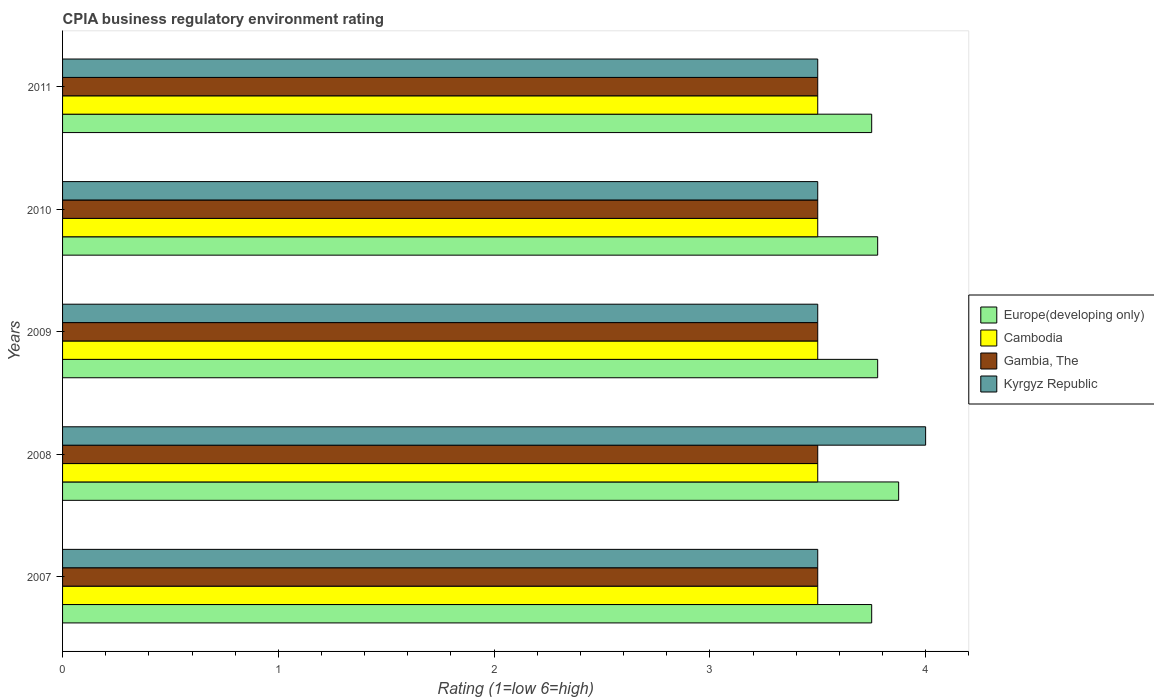How many groups of bars are there?
Give a very brief answer. 5. How many bars are there on the 5th tick from the top?
Offer a very short reply. 4. How many bars are there on the 1st tick from the bottom?
Keep it short and to the point. 4. What is the label of the 2nd group of bars from the top?
Offer a very short reply. 2010. In how many cases, is the number of bars for a given year not equal to the number of legend labels?
Your response must be concise. 0. Across all years, what is the maximum CPIA rating in Europe(developing only)?
Offer a very short reply. 3.88. What is the difference between the CPIA rating in Gambia, The in 2009 and that in 2010?
Give a very brief answer. 0. What is the difference between the CPIA rating in Cambodia in 2009 and the CPIA rating in Europe(developing only) in 2011?
Your response must be concise. -0.25. What is the average CPIA rating in Gambia, The per year?
Provide a succinct answer. 3.5. In the year 2010, what is the difference between the CPIA rating in Cambodia and CPIA rating in Europe(developing only)?
Offer a terse response. -0.28. What is the difference between the highest and the lowest CPIA rating in Europe(developing only)?
Offer a terse response. 0.12. What does the 4th bar from the top in 2011 represents?
Make the answer very short. Europe(developing only). What does the 3rd bar from the bottom in 2010 represents?
Provide a short and direct response. Gambia, The. Are all the bars in the graph horizontal?
Ensure brevity in your answer.  Yes. How many years are there in the graph?
Provide a short and direct response. 5. What is the difference between two consecutive major ticks on the X-axis?
Offer a very short reply. 1. Are the values on the major ticks of X-axis written in scientific E-notation?
Your response must be concise. No. Does the graph contain any zero values?
Offer a very short reply. No. Does the graph contain grids?
Give a very brief answer. No. How many legend labels are there?
Provide a succinct answer. 4. What is the title of the graph?
Provide a short and direct response. CPIA business regulatory environment rating. What is the Rating (1=low 6=high) in Europe(developing only) in 2007?
Provide a short and direct response. 3.75. What is the Rating (1=low 6=high) of Cambodia in 2007?
Ensure brevity in your answer.  3.5. What is the Rating (1=low 6=high) in Gambia, The in 2007?
Offer a terse response. 3.5. What is the Rating (1=low 6=high) of Europe(developing only) in 2008?
Offer a terse response. 3.88. What is the Rating (1=low 6=high) in Cambodia in 2008?
Provide a succinct answer. 3.5. What is the Rating (1=low 6=high) in Gambia, The in 2008?
Offer a terse response. 3.5. What is the Rating (1=low 6=high) of Europe(developing only) in 2009?
Provide a succinct answer. 3.78. What is the Rating (1=low 6=high) in Europe(developing only) in 2010?
Your answer should be compact. 3.78. What is the Rating (1=low 6=high) in Europe(developing only) in 2011?
Make the answer very short. 3.75. Across all years, what is the maximum Rating (1=low 6=high) in Europe(developing only)?
Offer a terse response. 3.88. Across all years, what is the maximum Rating (1=low 6=high) of Gambia, The?
Provide a succinct answer. 3.5. Across all years, what is the minimum Rating (1=low 6=high) in Europe(developing only)?
Keep it short and to the point. 3.75. Across all years, what is the minimum Rating (1=low 6=high) in Cambodia?
Provide a succinct answer. 3.5. Across all years, what is the minimum Rating (1=low 6=high) in Gambia, The?
Make the answer very short. 3.5. Across all years, what is the minimum Rating (1=low 6=high) in Kyrgyz Republic?
Provide a short and direct response. 3.5. What is the total Rating (1=low 6=high) of Europe(developing only) in the graph?
Provide a short and direct response. 18.93. What is the total Rating (1=low 6=high) of Cambodia in the graph?
Offer a very short reply. 17.5. What is the difference between the Rating (1=low 6=high) in Europe(developing only) in 2007 and that in 2008?
Your answer should be compact. -0.12. What is the difference between the Rating (1=low 6=high) of Cambodia in 2007 and that in 2008?
Offer a very short reply. 0. What is the difference between the Rating (1=low 6=high) of Europe(developing only) in 2007 and that in 2009?
Your response must be concise. -0.03. What is the difference between the Rating (1=low 6=high) in Cambodia in 2007 and that in 2009?
Your answer should be compact. 0. What is the difference between the Rating (1=low 6=high) of Gambia, The in 2007 and that in 2009?
Offer a terse response. 0. What is the difference between the Rating (1=low 6=high) of Kyrgyz Republic in 2007 and that in 2009?
Your answer should be very brief. 0. What is the difference between the Rating (1=low 6=high) of Europe(developing only) in 2007 and that in 2010?
Provide a succinct answer. -0.03. What is the difference between the Rating (1=low 6=high) in Gambia, The in 2007 and that in 2010?
Provide a short and direct response. 0. What is the difference between the Rating (1=low 6=high) of Kyrgyz Republic in 2007 and that in 2010?
Offer a terse response. 0. What is the difference between the Rating (1=low 6=high) of Cambodia in 2007 and that in 2011?
Provide a short and direct response. 0. What is the difference between the Rating (1=low 6=high) in Gambia, The in 2007 and that in 2011?
Give a very brief answer. 0. What is the difference between the Rating (1=low 6=high) of Kyrgyz Republic in 2007 and that in 2011?
Make the answer very short. 0. What is the difference between the Rating (1=low 6=high) in Europe(developing only) in 2008 and that in 2009?
Your answer should be compact. 0.1. What is the difference between the Rating (1=low 6=high) in Cambodia in 2008 and that in 2009?
Provide a succinct answer. 0. What is the difference between the Rating (1=low 6=high) in Europe(developing only) in 2008 and that in 2010?
Give a very brief answer. 0.1. What is the difference between the Rating (1=low 6=high) of Gambia, The in 2008 and that in 2010?
Your answer should be compact. 0. What is the difference between the Rating (1=low 6=high) in Kyrgyz Republic in 2008 and that in 2010?
Ensure brevity in your answer.  0.5. What is the difference between the Rating (1=low 6=high) of Cambodia in 2008 and that in 2011?
Your answer should be compact. 0. What is the difference between the Rating (1=low 6=high) of Europe(developing only) in 2009 and that in 2010?
Provide a succinct answer. 0. What is the difference between the Rating (1=low 6=high) in Gambia, The in 2009 and that in 2010?
Ensure brevity in your answer.  0. What is the difference between the Rating (1=low 6=high) in Kyrgyz Republic in 2009 and that in 2010?
Ensure brevity in your answer.  0. What is the difference between the Rating (1=low 6=high) of Europe(developing only) in 2009 and that in 2011?
Provide a succinct answer. 0.03. What is the difference between the Rating (1=low 6=high) of Europe(developing only) in 2010 and that in 2011?
Provide a short and direct response. 0.03. What is the difference between the Rating (1=low 6=high) of Cambodia in 2010 and that in 2011?
Keep it short and to the point. 0. What is the difference between the Rating (1=low 6=high) in Kyrgyz Republic in 2010 and that in 2011?
Make the answer very short. 0. What is the difference between the Rating (1=low 6=high) in Europe(developing only) in 2007 and the Rating (1=low 6=high) in Cambodia in 2008?
Keep it short and to the point. 0.25. What is the difference between the Rating (1=low 6=high) of Europe(developing only) in 2007 and the Rating (1=low 6=high) of Gambia, The in 2008?
Make the answer very short. 0.25. What is the difference between the Rating (1=low 6=high) in Europe(developing only) in 2007 and the Rating (1=low 6=high) in Kyrgyz Republic in 2008?
Offer a very short reply. -0.25. What is the difference between the Rating (1=low 6=high) in Cambodia in 2007 and the Rating (1=low 6=high) in Kyrgyz Republic in 2008?
Offer a very short reply. -0.5. What is the difference between the Rating (1=low 6=high) in Gambia, The in 2007 and the Rating (1=low 6=high) in Kyrgyz Republic in 2008?
Give a very brief answer. -0.5. What is the difference between the Rating (1=low 6=high) of Europe(developing only) in 2007 and the Rating (1=low 6=high) of Cambodia in 2009?
Offer a terse response. 0.25. What is the difference between the Rating (1=low 6=high) in Europe(developing only) in 2007 and the Rating (1=low 6=high) in Gambia, The in 2009?
Ensure brevity in your answer.  0.25. What is the difference between the Rating (1=low 6=high) in Cambodia in 2007 and the Rating (1=low 6=high) in Gambia, The in 2009?
Your answer should be very brief. 0. What is the difference between the Rating (1=low 6=high) in Europe(developing only) in 2007 and the Rating (1=low 6=high) in Cambodia in 2010?
Provide a short and direct response. 0.25. What is the difference between the Rating (1=low 6=high) in Europe(developing only) in 2007 and the Rating (1=low 6=high) in Gambia, The in 2010?
Your answer should be very brief. 0.25. What is the difference between the Rating (1=low 6=high) in Cambodia in 2007 and the Rating (1=low 6=high) in Gambia, The in 2010?
Offer a very short reply. 0. What is the difference between the Rating (1=low 6=high) in Europe(developing only) in 2007 and the Rating (1=low 6=high) in Cambodia in 2011?
Your answer should be very brief. 0.25. What is the difference between the Rating (1=low 6=high) of Europe(developing only) in 2007 and the Rating (1=low 6=high) of Gambia, The in 2011?
Ensure brevity in your answer.  0.25. What is the difference between the Rating (1=low 6=high) of Europe(developing only) in 2007 and the Rating (1=low 6=high) of Kyrgyz Republic in 2011?
Ensure brevity in your answer.  0.25. What is the difference between the Rating (1=low 6=high) of Cambodia in 2007 and the Rating (1=low 6=high) of Gambia, The in 2011?
Make the answer very short. 0. What is the difference between the Rating (1=low 6=high) in Europe(developing only) in 2008 and the Rating (1=low 6=high) in Cambodia in 2009?
Keep it short and to the point. 0.38. What is the difference between the Rating (1=low 6=high) of Europe(developing only) in 2008 and the Rating (1=low 6=high) of Gambia, The in 2009?
Give a very brief answer. 0.38. What is the difference between the Rating (1=low 6=high) in Europe(developing only) in 2008 and the Rating (1=low 6=high) in Cambodia in 2010?
Give a very brief answer. 0.38. What is the difference between the Rating (1=low 6=high) of Europe(developing only) in 2008 and the Rating (1=low 6=high) of Kyrgyz Republic in 2010?
Offer a very short reply. 0.38. What is the difference between the Rating (1=low 6=high) in Cambodia in 2008 and the Rating (1=low 6=high) in Gambia, The in 2010?
Offer a terse response. 0. What is the difference between the Rating (1=low 6=high) in Cambodia in 2008 and the Rating (1=low 6=high) in Kyrgyz Republic in 2010?
Ensure brevity in your answer.  0. What is the difference between the Rating (1=low 6=high) of Gambia, The in 2008 and the Rating (1=low 6=high) of Kyrgyz Republic in 2010?
Your answer should be very brief. 0. What is the difference between the Rating (1=low 6=high) of Europe(developing only) in 2008 and the Rating (1=low 6=high) of Cambodia in 2011?
Provide a short and direct response. 0.38. What is the difference between the Rating (1=low 6=high) of Cambodia in 2008 and the Rating (1=low 6=high) of Kyrgyz Republic in 2011?
Offer a terse response. 0. What is the difference between the Rating (1=low 6=high) in Europe(developing only) in 2009 and the Rating (1=low 6=high) in Cambodia in 2010?
Make the answer very short. 0.28. What is the difference between the Rating (1=low 6=high) in Europe(developing only) in 2009 and the Rating (1=low 6=high) in Gambia, The in 2010?
Provide a succinct answer. 0.28. What is the difference between the Rating (1=low 6=high) of Europe(developing only) in 2009 and the Rating (1=low 6=high) of Kyrgyz Republic in 2010?
Your answer should be very brief. 0.28. What is the difference between the Rating (1=low 6=high) in Cambodia in 2009 and the Rating (1=low 6=high) in Gambia, The in 2010?
Provide a succinct answer. 0. What is the difference between the Rating (1=low 6=high) of Europe(developing only) in 2009 and the Rating (1=low 6=high) of Cambodia in 2011?
Keep it short and to the point. 0.28. What is the difference between the Rating (1=low 6=high) in Europe(developing only) in 2009 and the Rating (1=low 6=high) in Gambia, The in 2011?
Provide a short and direct response. 0.28. What is the difference between the Rating (1=low 6=high) in Europe(developing only) in 2009 and the Rating (1=low 6=high) in Kyrgyz Republic in 2011?
Your response must be concise. 0.28. What is the difference between the Rating (1=low 6=high) in Cambodia in 2009 and the Rating (1=low 6=high) in Kyrgyz Republic in 2011?
Make the answer very short. 0. What is the difference between the Rating (1=low 6=high) of Gambia, The in 2009 and the Rating (1=low 6=high) of Kyrgyz Republic in 2011?
Provide a succinct answer. 0. What is the difference between the Rating (1=low 6=high) of Europe(developing only) in 2010 and the Rating (1=low 6=high) of Cambodia in 2011?
Your response must be concise. 0.28. What is the difference between the Rating (1=low 6=high) in Europe(developing only) in 2010 and the Rating (1=low 6=high) in Gambia, The in 2011?
Offer a very short reply. 0.28. What is the difference between the Rating (1=low 6=high) in Europe(developing only) in 2010 and the Rating (1=low 6=high) in Kyrgyz Republic in 2011?
Your answer should be very brief. 0.28. What is the average Rating (1=low 6=high) in Europe(developing only) per year?
Ensure brevity in your answer.  3.79. What is the average Rating (1=low 6=high) of Kyrgyz Republic per year?
Provide a short and direct response. 3.6. In the year 2007, what is the difference between the Rating (1=low 6=high) in Europe(developing only) and Rating (1=low 6=high) in Cambodia?
Your response must be concise. 0.25. In the year 2007, what is the difference between the Rating (1=low 6=high) in Europe(developing only) and Rating (1=low 6=high) in Kyrgyz Republic?
Offer a terse response. 0.25. In the year 2007, what is the difference between the Rating (1=low 6=high) in Cambodia and Rating (1=low 6=high) in Gambia, The?
Offer a very short reply. 0. In the year 2008, what is the difference between the Rating (1=low 6=high) in Europe(developing only) and Rating (1=low 6=high) in Gambia, The?
Your response must be concise. 0.38. In the year 2008, what is the difference between the Rating (1=low 6=high) of Europe(developing only) and Rating (1=low 6=high) of Kyrgyz Republic?
Offer a terse response. -0.12. In the year 2009, what is the difference between the Rating (1=low 6=high) in Europe(developing only) and Rating (1=low 6=high) in Cambodia?
Your answer should be very brief. 0.28. In the year 2009, what is the difference between the Rating (1=low 6=high) in Europe(developing only) and Rating (1=low 6=high) in Gambia, The?
Keep it short and to the point. 0.28. In the year 2009, what is the difference between the Rating (1=low 6=high) in Europe(developing only) and Rating (1=low 6=high) in Kyrgyz Republic?
Your answer should be compact. 0.28. In the year 2010, what is the difference between the Rating (1=low 6=high) in Europe(developing only) and Rating (1=low 6=high) in Cambodia?
Ensure brevity in your answer.  0.28. In the year 2010, what is the difference between the Rating (1=low 6=high) of Europe(developing only) and Rating (1=low 6=high) of Gambia, The?
Make the answer very short. 0.28. In the year 2010, what is the difference between the Rating (1=low 6=high) in Europe(developing only) and Rating (1=low 6=high) in Kyrgyz Republic?
Your response must be concise. 0.28. In the year 2011, what is the difference between the Rating (1=low 6=high) of Europe(developing only) and Rating (1=low 6=high) of Cambodia?
Your response must be concise. 0.25. In the year 2011, what is the difference between the Rating (1=low 6=high) in Cambodia and Rating (1=low 6=high) in Gambia, The?
Your response must be concise. 0. In the year 2011, what is the difference between the Rating (1=low 6=high) of Cambodia and Rating (1=low 6=high) of Kyrgyz Republic?
Your response must be concise. 0. What is the ratio of the Rating (1=low 6=high) of Europe(developing only) in 2007 to that in 2008?
Ensure brevity in your answer.  0.97. What is the ratio of the Rating (1=low 6=high) of Europe(developing only) in 2007 to that in 2009?
Make the answer very short. 0.99. What is the ratio of the Rating (1=low 6=high) in Gambia, The in 2007 to that in 2009?
Provide a short and direct response. 1. What is the ratio of the Rating (1=low 6=high) in Europe(developing only) in 2007 to that in 2010?
Your answer should be very brief. 0.99. What is the ratio of the Rating (1=low 6=high) in Gambia, The in 2007 to that in 2010?
Make the answer very short. 1. What is the ratio of the Rating (1=low 6=high) in Kyrgyz Republic in 2007 to that in 2010?
Provide a succinct answer. 1. What is the ratio of the Rating (1=low 6=high) of Europe(developing only) in 2007 to that in 2011?
Keep it short and to the point. 1. What is the ratio of the Rating (1=low 6=high) of Cambodia in 2007 to that in 2011?
Provide a short and direct response. 1. What is the ratio of the Rating (1=low 6=high) of Kyrgyz Republic in 2007 to that in 2011?
Provide a succinct answer. 1. What is the ratio of the Rating (1=low 6=high) of Europe(developing only) in 2008 to that in 2009?
Offer a terse response. 1.03. What is the ratio of the Rating (1=low 6=high) in Europe(developing only) in 2008 to that in 2010?
Ensure brevity in your answer.  1.03. What is the ratio of the Rating (1=low 6=high) in Cambodia in 2008 to that in 2010?
Offer a terse response. 1. What is the ratio of the Rating (1=low 6=high) in Gambia, The in 2008 to that in 2010?
Make the answer very short. 1. What is the ratio of the Rating (1=low 6=high) in Kyrgyz Republic in 2008 to that in 2011?
Keep it short and to the point. 1.14. What is the ratio of the Rating (1=low 6=high) of Europe(developing only) in 2009 to that in 2010?
Keep it short and to the point. 1. What is the ratio of the Rating (1=low 6=high) in Cambodia in 2009 to that in 2010?
Your answer should be very brief. 1. What is the ratio of the Rating (1=low 6=high) in Gambia, The in 2009 to that in 2010?
Ensure brevity in your answer.  1. What is the ratio of the Rating (1=low 6=high) in Kyrgyz Republic in 2009 to that in 2010?
Offer a terse response. 1. What is the ratio of the Rating (1=low 6=high) in Europe(developing only) in 2009 to that in 2011?
Offer a terse response. 1.01. What is the ratio of the Rating (1=low 6=high) in Cambodia in 2009 to that in 2011?
Keep it short and to the point. 1. What is the ratio of the Rating (1=low 6=high) of Gambia, The in 2009 to that in 2011?
Your answer should be very brief. 1. What is the ratio of the Rating (1=low 6=high) of Kyrgyz Republic in 2009 to that in 2011?
Provide a short and direct response. 1. What is the ratio of the Rating (1=low 6=high) in Europe(developing only) in 2010 to that in 2011?
Keep it short and to the point. 1.01. What is the ratio of the Rating (1=low 6=high) of Gambia, The in 2010 to that in 2011?
Your answer should be compact. 1. What is the difference between the highest and the second highest Rating (1=low 6=high) of Europe(developing only)?
Provide a short and direct response. 0.1. What is the difference between the highest and the second highest Rating (1=low 6=high) in Cambodia?
Offer a very short reply. 0. What is the difference between the highest and the second highest Rating (1=low 6=high) in Gambia, The?
Offer a terse response. 0. 